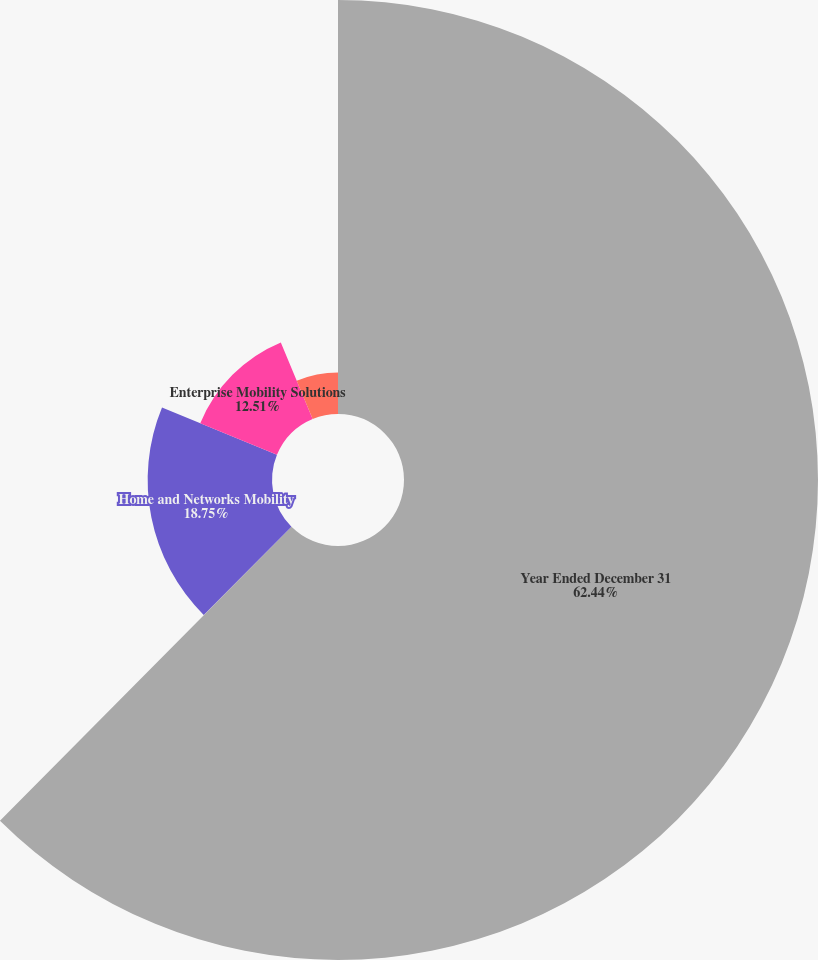Convert chart. <chart><loc_0><loc_0><loc_500><loc_500><pie_chart><fcel>Year Ended December 31<fcel>Mobile Devices<fcel>Home and Networks Mobility<fcel>Enterprise Mobility Solutions<fcel>General Corporate<nl><fcel>62.43%<fcel>0.03%<fcel>18.75%<fcel>12.51%<fcel>6.27%<nl></chart> 